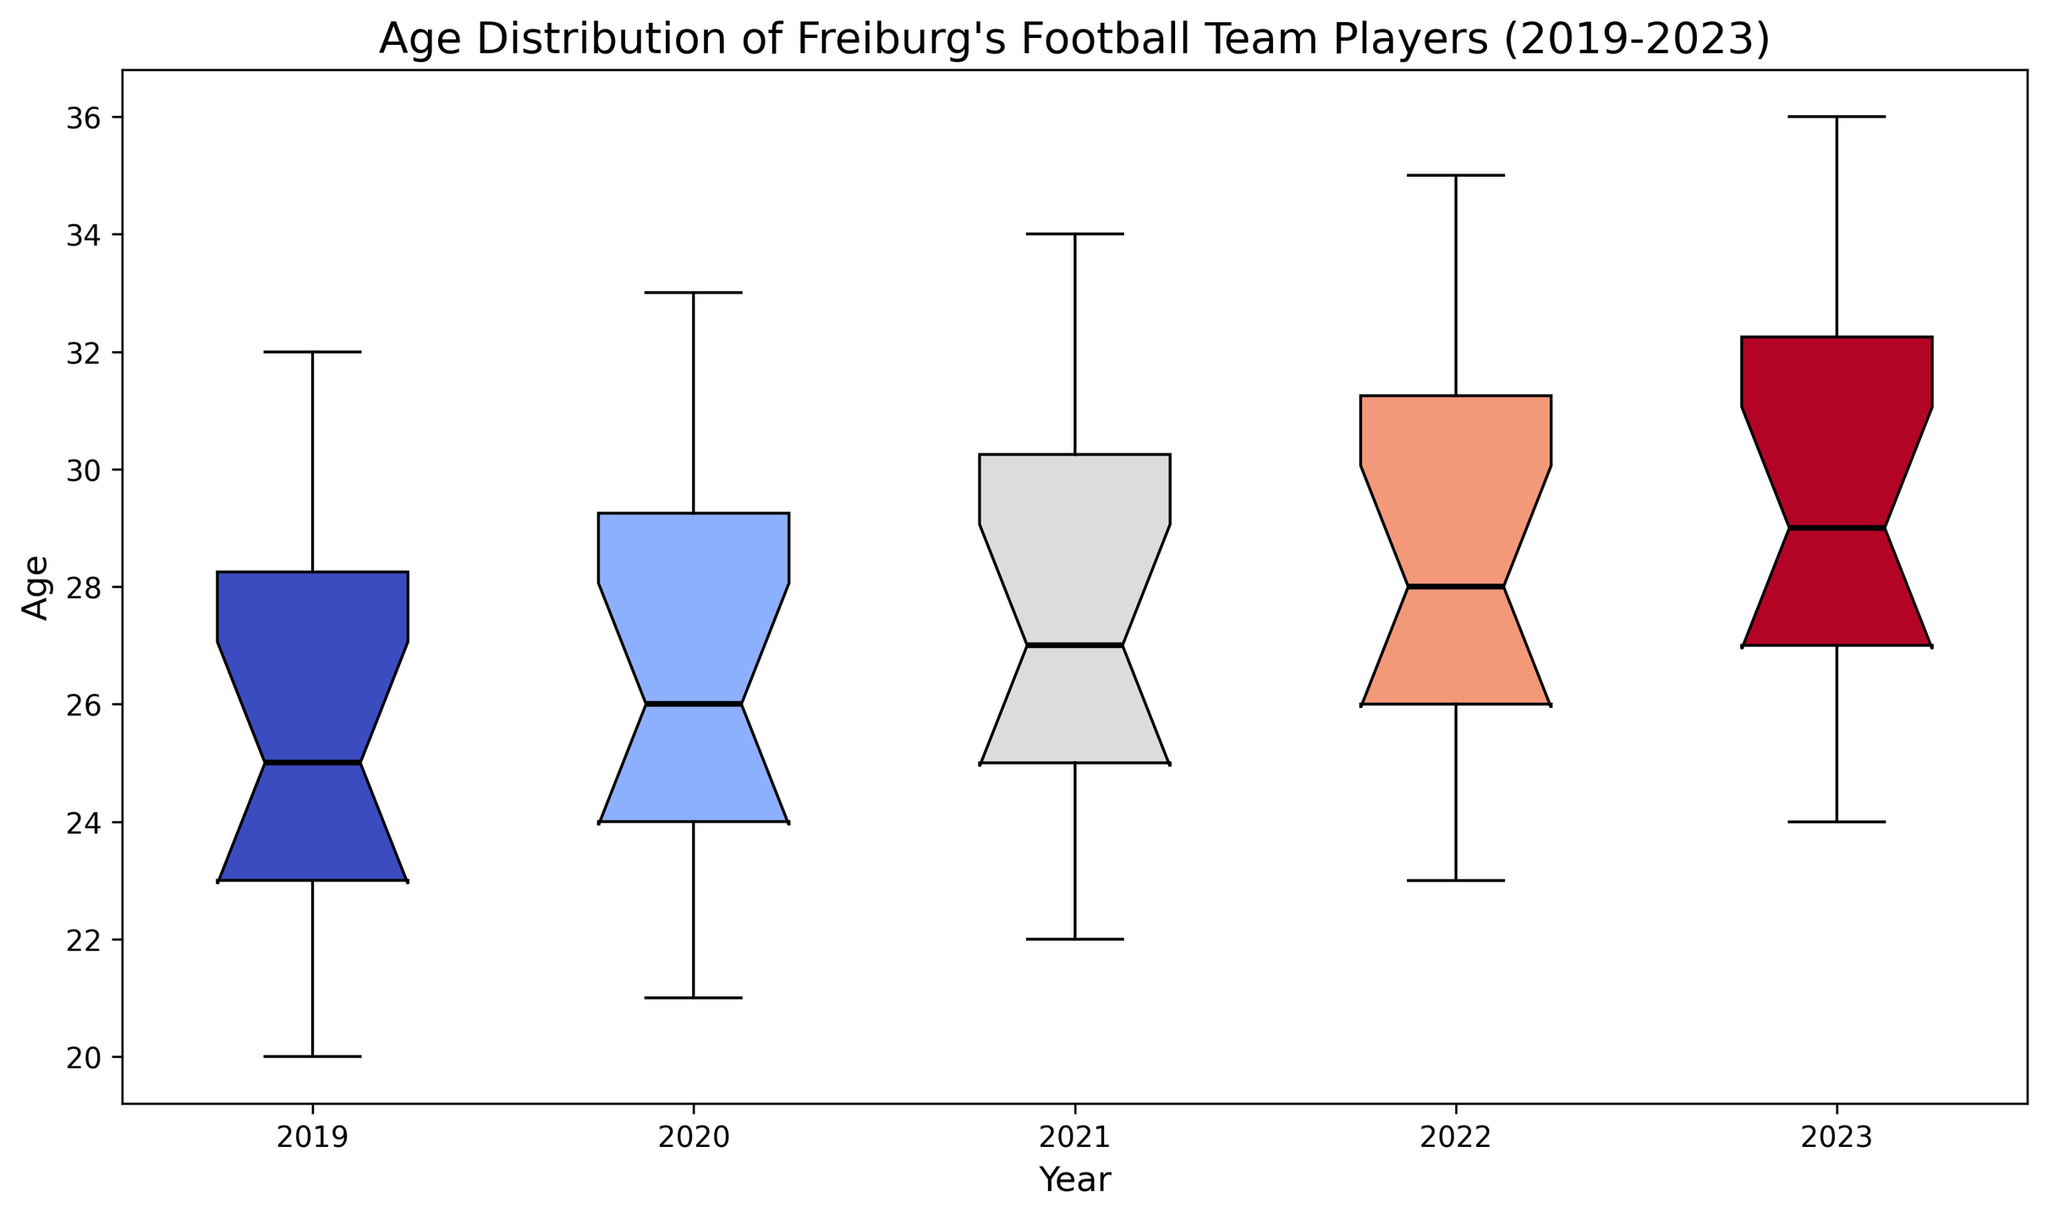Which year has the youngest median age? In the box plot, look for the median lines inside the boxes. Compare the position of these median lines across all years; the year with the lowest median line represents the youngest median age.
Answer: 2019 What's the interquartile range (IQR) of the ages in 2021? The IQR is the difference between the third quartile (Q3) and the first quartile (Q1). Identify Q3 and Q1 for 2021 by looking at the top and bottom of the box, respectively. Subtract Q1 from Q3.
Answer: 6 Which year has the greatest range in ages? The range is the difference between the maximum and minimum values. Look for the overall length of the whiskers (vertical lines) for each year and identify the year with the longest whiskers.
Answer: 2019 How many years have a median age of 28 or higher? Observe the position of the median lines (horizontal line inside the boxes) and count the number of years where the median line is at 28 or higher on the y-axis.
Answer: 4 Did the median age increase or decrease from 2019 to 2023? Compare the median lines (horizontal line inside the boxes) in 2019 and 2023. Check if the median line in 2023 is higher or lower than in 2019.
Answer: Increase Which year shows the least variability in ages? Variability can be observed by looking at the height of the boxes, with smaller boxes indicating less variability. Identify the year with the smallest box height.
Answer: 2023 What is the median age in 2020? Locate the median line (horizontal line inside the box) for the year 2020 and note the value on the y-axis where this line is positioned.
Answer: 26 Is there any year where the median, minimum, and first quartile are all below 25? For each year, look at the median line, minimum whisker, and bottom of the box. See if all these marks fall below the age 25 line on the y-axis for any given year.
Answer: 2019 Which year had the maximum age of any player the highest? Compare the top whiskers (vertical lines) across all years and identify the year where the top whisker is the highest on the y-axis.
Answer: 2023 How does the interquartile range (IQR) change from 2020 to 2021? Determine the IQR (difference between Q3 and Q1) for each year, then compare the two values to see if it has increased, decreased, or remained the same.
Answer: Increase 